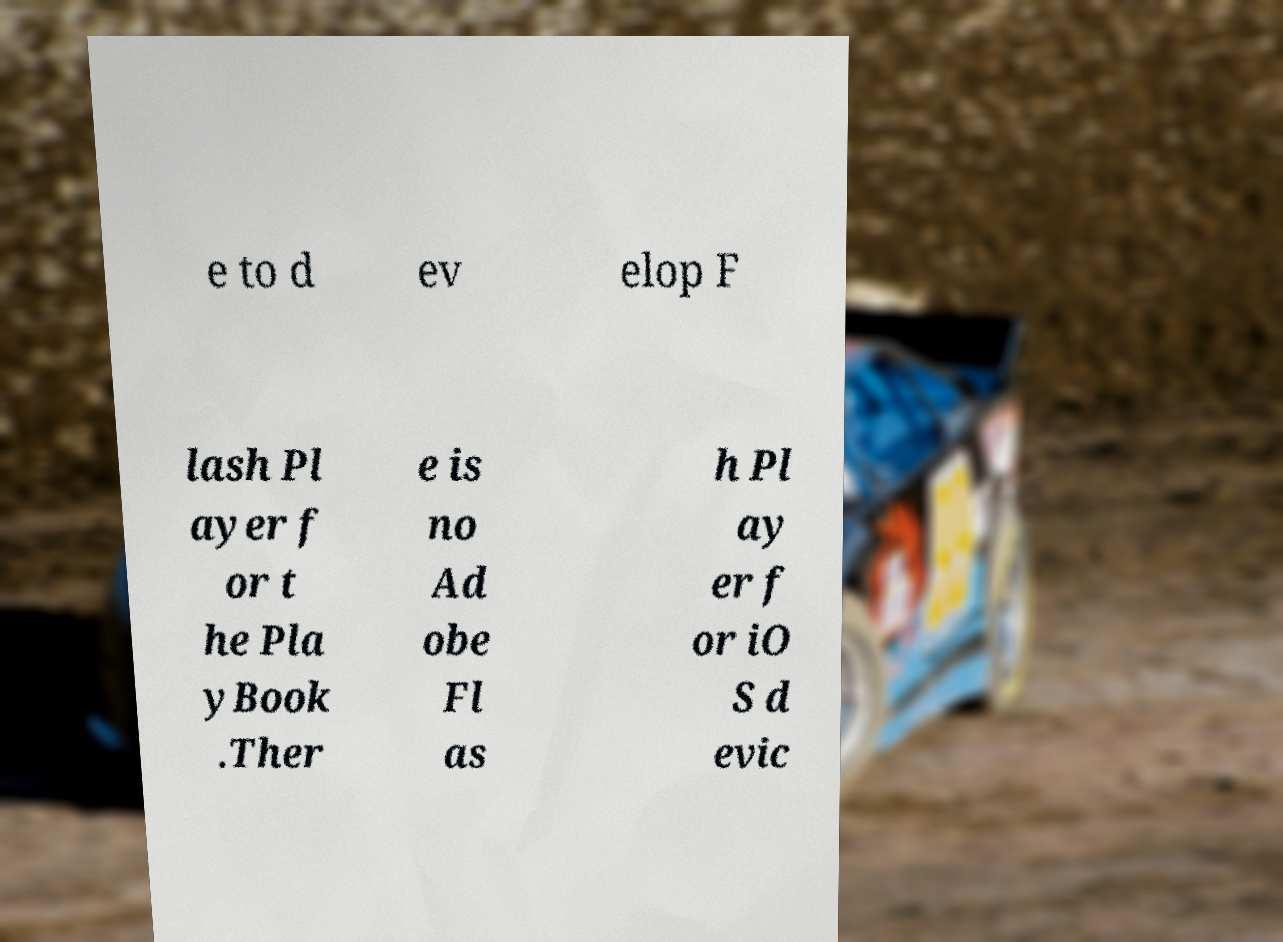For documentation purposes, I need the text within this image transcribed. Could you provide that? e to d ev elop F lash Pl ayer f or t he Pla yBook .Ther e is no Ad obe Fl as h Pl ay er f or iO S d evic 